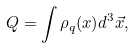<formula> <loc_0><loc_0><loc_500><loc_500>Q = \int \rho _ { q } ( x ) d ^ { 3 } \vec { x } ,</formula> 